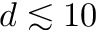Convert formula to latex. <formula><loc_0><loc_0><loc_500><loc_500>d \lesssim 1 0</formula> 